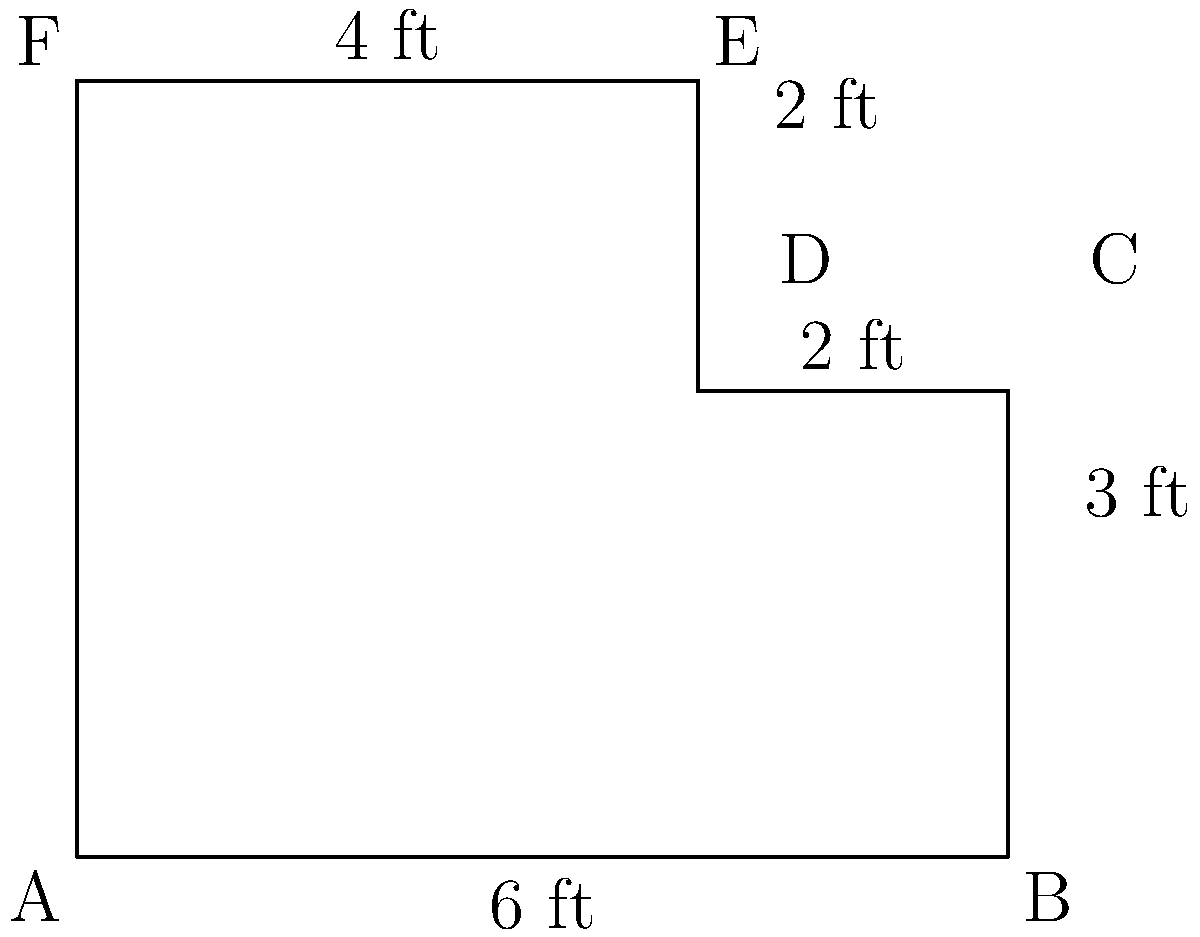You need to measure the kitchen counter for new edging in the elderly woman's home. The counter has an irregular shape as shown in the diagram. Calculate the perimeter of the counter in feet. To find the perimeter of the irregular kitchen counter, we need to add up the lengths of all sides:

1. Side AB: 6 ft
2. Side BC: 3 ft
3. Side CD: 2 ft
4. Side DE: 2 ft
5. Side EF: 4 ft
6. Side FA: 5 ft (vertical distance from A to F)

Now, let's add all these lengths:

$$ \text{Perimeter} = 6 + 3 + 2 + 2 + 4 + 5 = 22 \text{ ft} $$

Therefore, the perimeter of the kitchen counter is 22 feet.
Answer: 22 ft 